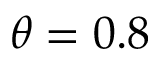<formula> <loc_0><loc_0><loc_500><loc_500>\theta = 0 . 8</formula> 